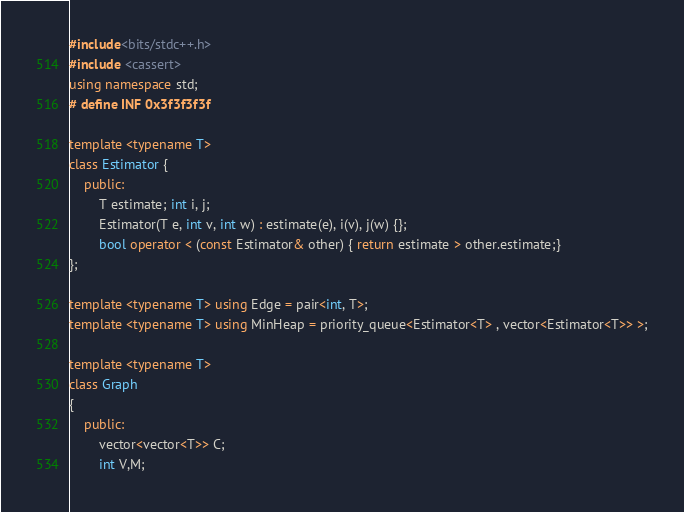Convert code to text. <code><loc_0><loc_0><loc_500><loc_500><_C++_>#include<bits/stdc++.h>
#include <cassert>
using namespace std;
# define INF 0x3f3f3f3f

template <typename T>
class Estimator {
	public:
		T estimate; int i, j;
		Estimator(T e, int v, int w) : estimate(e), i(v), j(w) {};
		bool operator < (const Estimator& other) { return estimate > other.estimate;}
};

template <typename T> using Edge = pair<int, T>;
template <typename T> using MinHeap = priority_queue<Estimator<T> , vector<Estimator<T>> >;

template <typename T>
class Graph
{
	public:
		vector<vector<T>> C;
	    int V,M;  </code> 